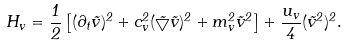Convert formula to latex. <formula><loc_0><loc_0><loc_500><loc_500>H _ { v } = \frac { 1 } { 2 } \left [ ( \partial _ { t } \vec { v } ) ^ { 2 } + c _ { v } ^ { 2 } ( \vec { \bigtriangledown } \vec { v } ) ^ { 2 } + m _ { v } ^ { 2 } \vec { v } ^ { 2 } \right ] + \frac { u _ { v } } { 4 } ( \vec { v } ^ { 2 } ) ^ { 2 } .</formula> 